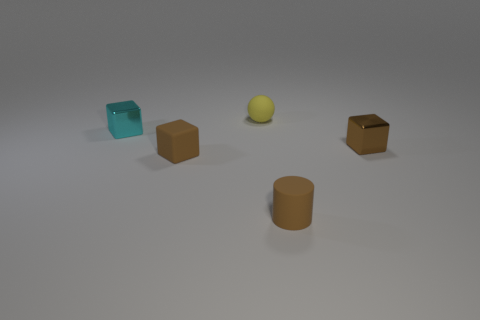Are there any other things that have the same size as the brown matte block?
Offer a very short reply. Yes. Do the tiny yellow thing and the brown cylinder have the same material?
Provide a short and direct response. Yes. There is a cyan object that is the same shape as the small brown metal object; what is it made of?
Provide a succinct answer. Metal. Is the number of small cyan things in front of the cyan cube less than the number of brown blocks?
Offer a terse response. Yes. What number of tiny metal cubes are to the right of the tiny brown metal object?
Give a very brief answer. 0. Is the shape of the brown object behind the brown matte cube the same as the brown rubber thing behind the matte cylinder?
Offer a very short reply. Yes. What shape is the thing that is both on the right side of the rubber block and left of the small brown cylinder?
Your response must be concise. Sphere. There is a brown cylinder that is made of the same material as the tiny yellow object; what is its size?
Ensure brevity in your answer.  Small. Are there fewer blue matte balls than tiny brown blocks?
Your answer should be compact. Yes. There is a small object that is in front of the cube in front of the small cube that is to the right of the small rubber sphere; what is it made of?
Provide a short and direct response. Rubber. 